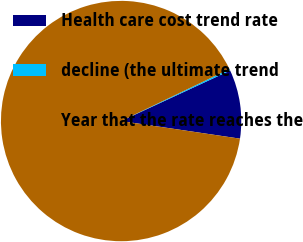Convert chart to OTSL. <chart><loc_0><loc_0><loc_500><loc_500><pie_chart><fcel>Health care cost trend rate<fcel>decline (the ultimate trend<fcel>Year that the rate reaches the<nl><fcel>9.25%<fcel>0.22%<fcel>90.52%<nl></chart> 